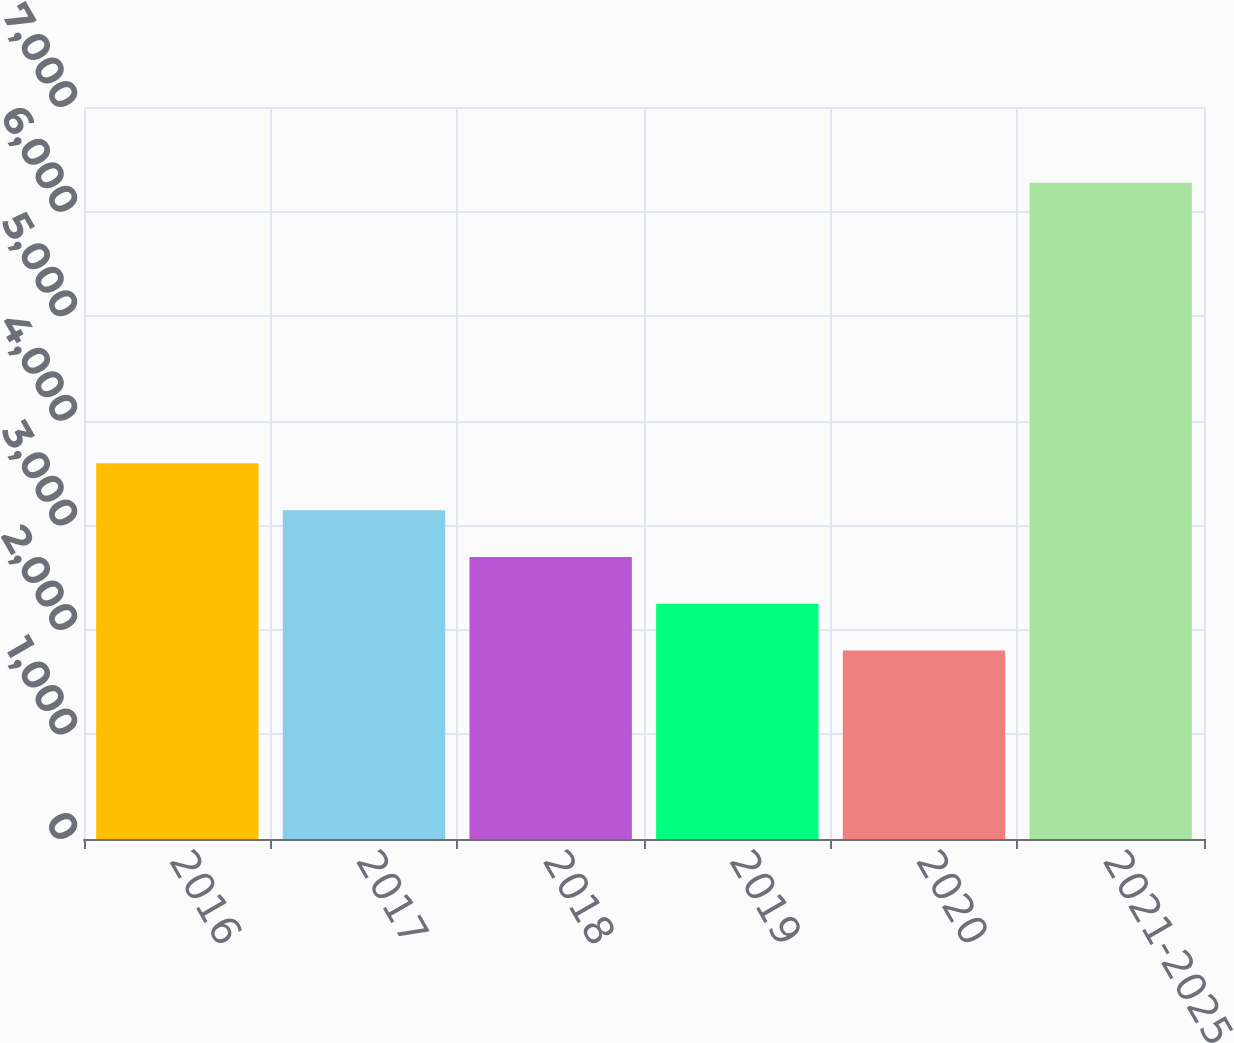<chart> <loc_0><loc_0><loc_500><loc_500><bar_chart><fcel>2016<fcel>2017<fcel>2018<fcel>2019<fcel>2020<fcel>2021-2025<nl><fcel>3592.2<fcel>3144.9<fcel>2697.6<fcel>2250.3<fcel>1803<fcel>6276<nl></chart> 